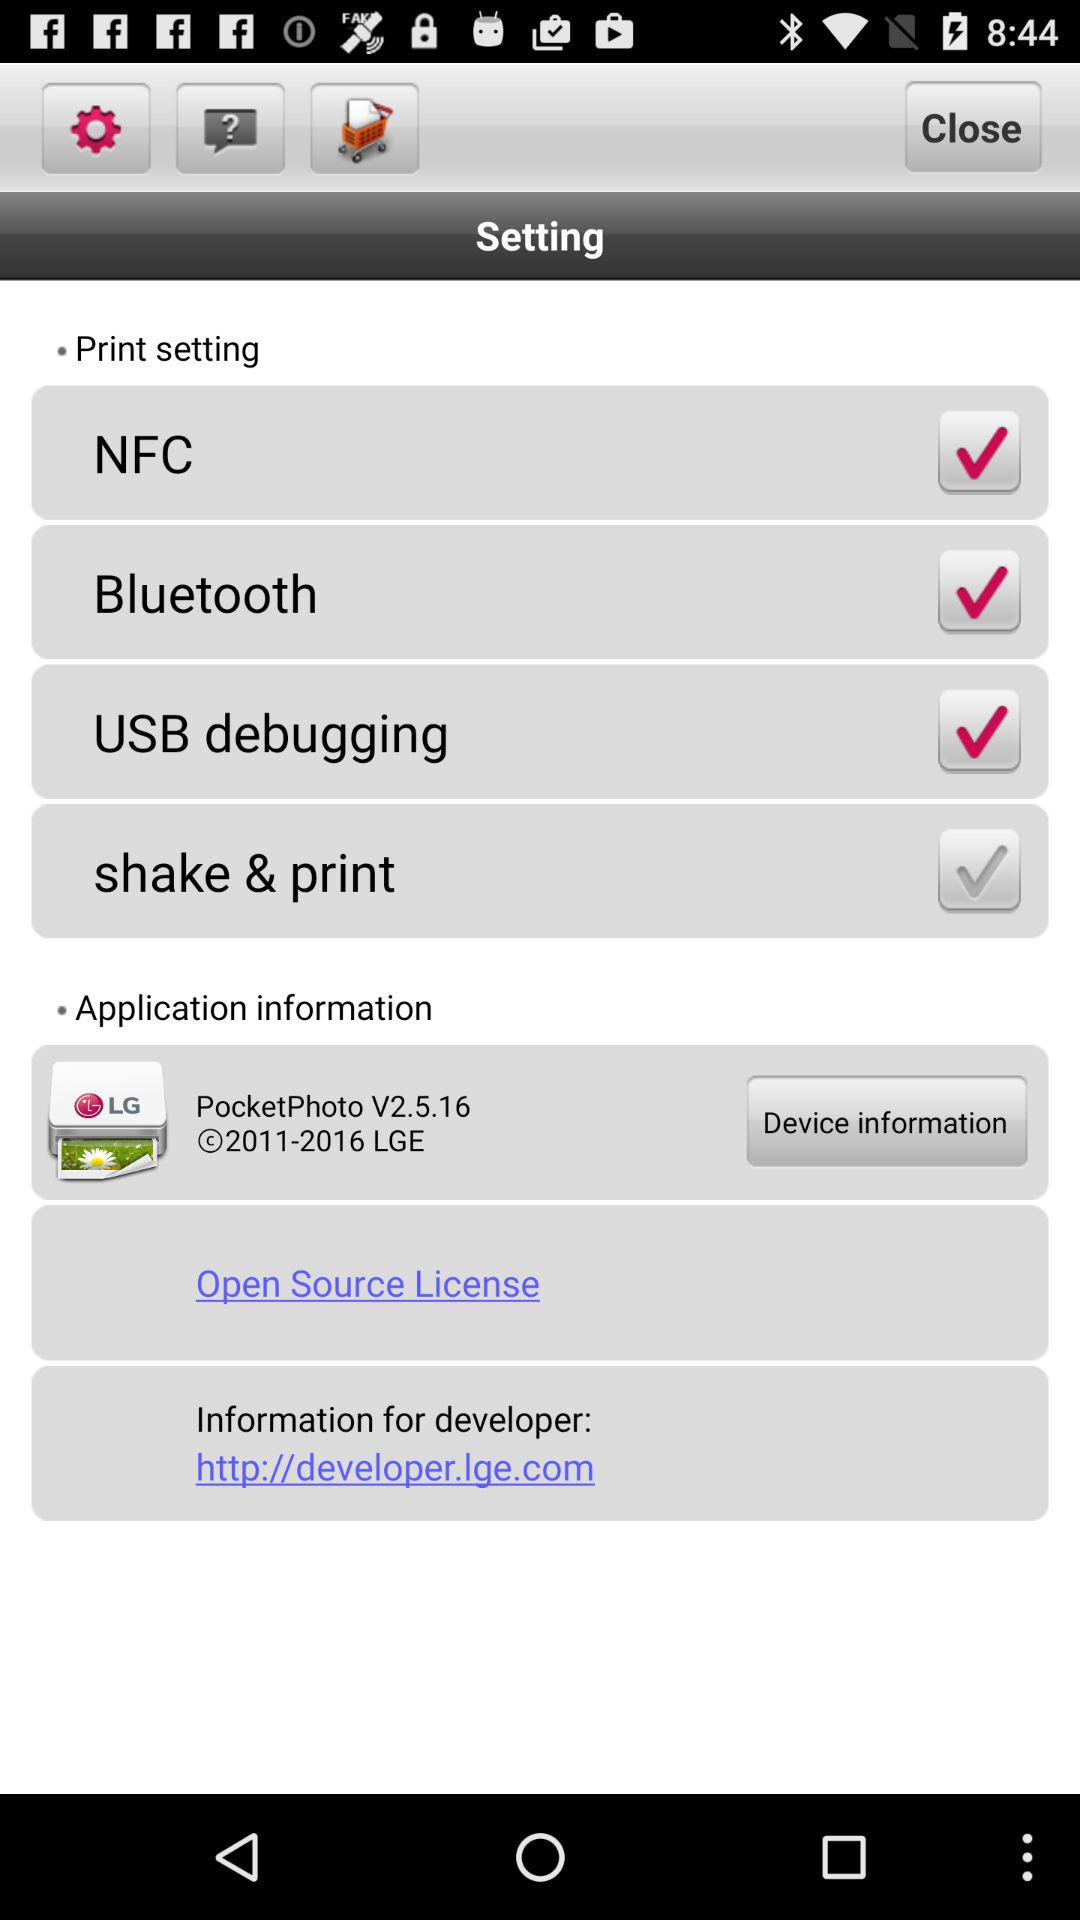Which options are checked? The checked options are "NFC", "Bluetooth" and "USB debugging". 